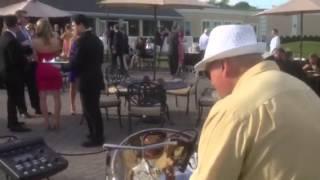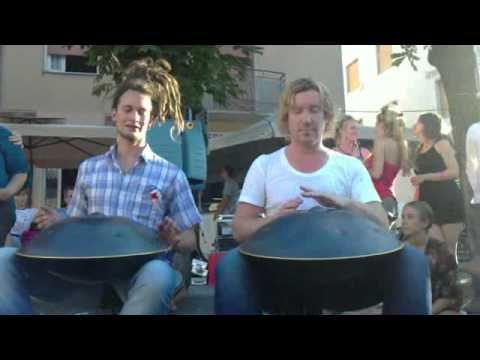The first image is the image on the left, the second image is the image on the right. Evaluate the accuracy of this statement regarding the images: "The left image features only man in a hawaiian shirt who is playing a silver-colored drum.". Is it true? Answer yes or no. No. The first image is the image on the left, the second image is the image on the right. Analyze the images presented: Is the assertion "The left and right image contains seven drums." valid? Answer yes or no. No. 